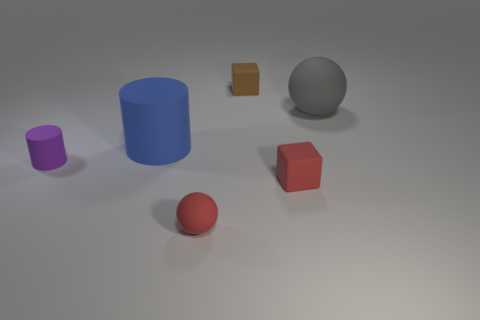Add 1 purple rubber things. How many objects exist? 7 Subtract all blue cylinders. How many cylinders are left? 1 Subtract all balls. How many objects are left? 4 Subtract all cyan balls. Subtract all cyan blocks. How many balls are left? 2 Subtract all gray matte objects. Subtract all brown objects. How many objects are left? 4 Add 6 tiny red balls. How many tiny red balls are left? 7 Add 5 small brown matte blocks. How many small brown matte blocks exist? 6 Subtract 0 green cubes. How many objects are left? 6 